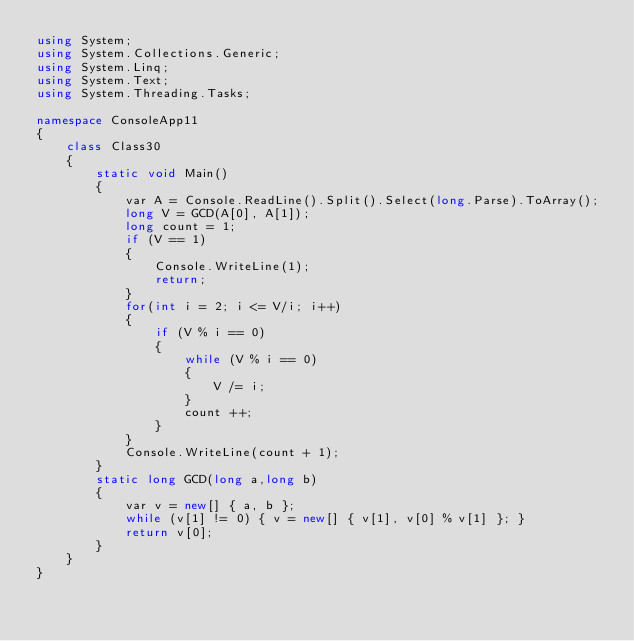Convert code to text. <code><loc_0><loc_0><loc_500><loc_500><_C#_>using System;
using System.Collections.Generic;
using System.Linq;
using System.Text;
using System.Threading.Tasks;

namespace ConsoleApp11
{
    class Class30
    {
        static void Main()
        {
            var A = Console.ReadLine().Split().Select(long.Parse).ToArray();
            long V = GCD(A[0], A[1]);
            long count = 1;
            if (V == 1)
            {
                Console.WriteLine(1);
                return;
            }
            for(int i = 2; i <= V/i; i++)
            {
                if (V % i == 0)
                {
                    while (V % i == 0)
                    {
                        V /= i;
                    }
                    count ++;
                }
            }
            Console.WriteLine(count + 1);
        }
        static long GCD(long a,long b)
        {
            var v = new[] { a, b };
            while (v[1] != 0) { v = new[] { v[1], v[0] % v[1] }; }
            return v[0];
        }
    }
}
</code> 